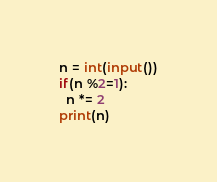Convert code to text. <code><loc_0><loc_0><loc_500><loc_500><_Python_>n = int(input())
if(n %2=1):
  n *= 2
print(n)</code> 